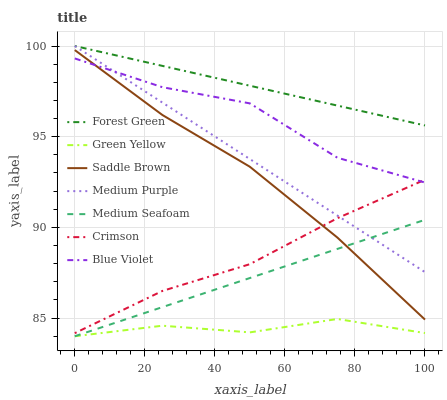Does Green Yellow have the minimum area under the curve?
Answer yes or no. Yes. Does Forest Green have the maximum area under the curve?
Answer yes or no. Yes. Does Medium Purple have the minimum area under the curve?
Answer yes or no. No. Does Medium Purple have the maximum area under the curve?
Answer yes or no. No. Is Forest Green the smoothest?
Answer yes or no. Yes. Is Blue Violet the roughest?
Answer yes or no. Yes. Is Medium Purple the smoothest?
Answer yes or no. No. Is Medium Purple the roughest?
Answer yes or no. No. Does Medium Purple have the lowest value?
Answer yes or no. No. Does Crimson have the highest value?
Answer yes or no. No. Is Blue Violet less than Forest Green?
Answer yes or no. Yes. Is Saddle Brown greater than Green Yellow?
Answer yes or no. Yes. Does Blue Violet intersect Forest Green?
Answer yes or no. No. 